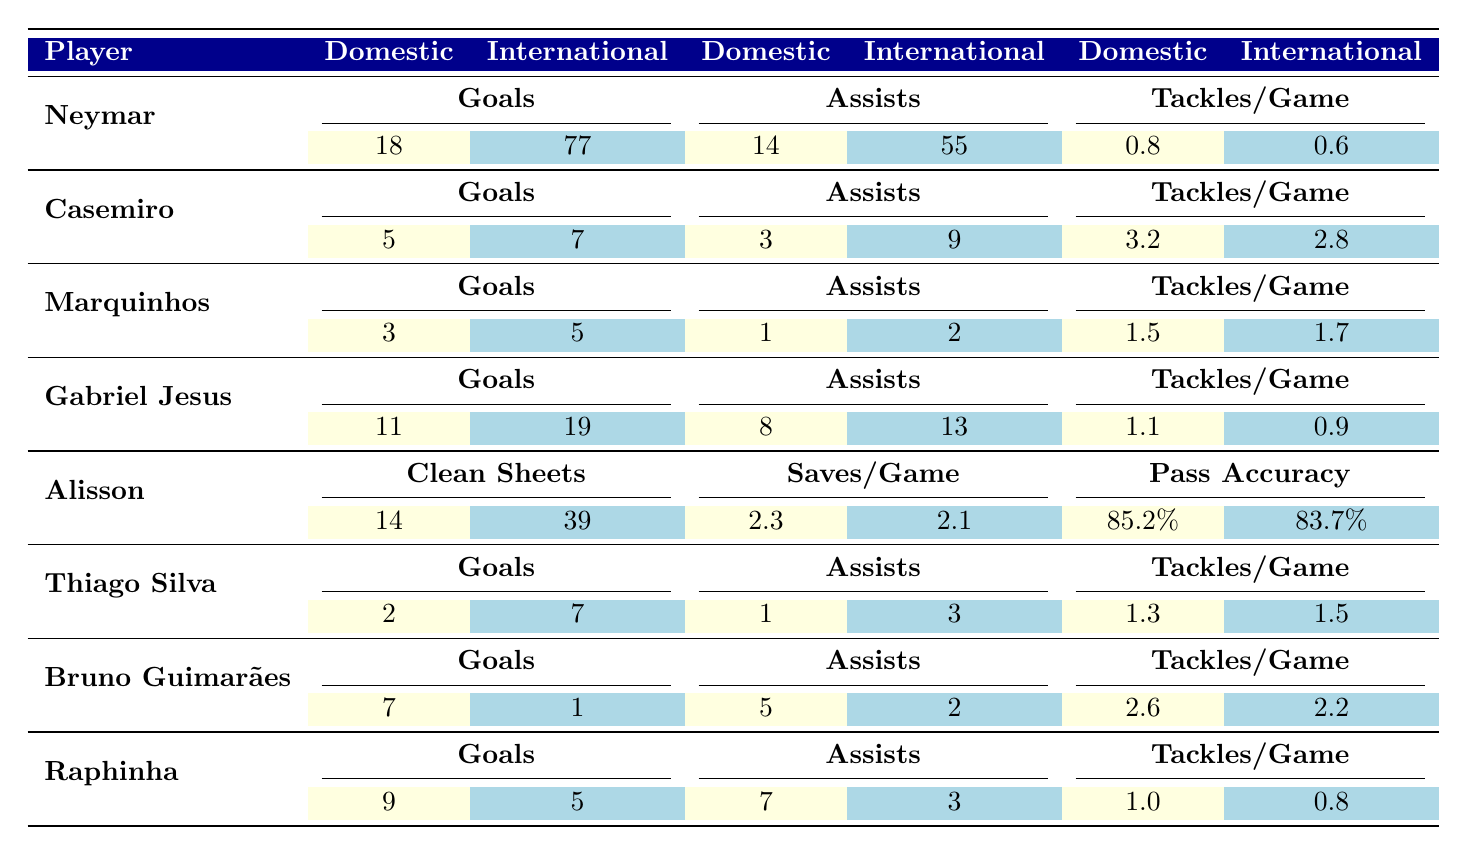What is Neymar's total number of goals scored in both domestic and international matches? Neymar scored 18 goals in domestic matches and 77 in international matches. Adding these together gives 18 + 77 = 95.
Answer: 95 Which player has the highest number of assists in international matches? By comparing the international assist values: Neymar has 55, Casemiro has 9, Gabriel Jesus has 13, Marquinhos has 2, Thiago Silva has 3, Bruno Guimarães has 2, and Raphinha has 3. The highest is Neymar with 55 assists.
Answer: Neymar What is the difference in tackles per game for Casemiro between domestic and international matches? Casemiro has 3.2 tackles per game domestically and 2.8 tackles per game internationally. The difference is 3.2 - 2.8 = 0.4 tackles per game.
Answer: 0.4 Is Gabriel Jesus more effective in terms of assists in domestic matches compared to international matches? Gabriel Jesus has 8 domestic assists and 13 international assists. Since 8 < 13, he is more effective internationally in terms of assists.
Answer: Yes What is the average number of goals scored by Thiago Silva across both match types? Thiago Silva scored 2 goals domestically and 7 internationally, totaling 2 + 7 = 9. Dividing this by the number of match types (2), the average is 9/2 = 4.5.
Answer: 4.5 How many clean sheets did Alisson keep more in international matches than domestic matches? Alisson recorded 39 clean sheets internationally and 14 domestically. The difference is 39 - 14 = 25 more clean sheets internationally.
Answer: 25 Which player has the most overall tackles per game when considering both contexts? The tackles per game for each are: Neymar (0.8, 0.6), Casemiro (3.2, 2.8), Marquinhos (1.5, 1.7), Gabriel Jesus (1.1, 0.9), Thiago Silva (1.3, 1.5), Bruno Guimarães (2.6, 2.2), and Raphinha (1.0, 0.8). Casemiro has the highest average of (3.2 + 2.8) / 2 = 3.0.
Answer: Casemiro What is the combined total of domestic assists from Raphinha and Bruno Guimarães? Raphinha has 7 domestic assists and Bruno Guimarães has 5. Adding these together gives 7 + 5 = 12.
Answer: 12 Did any player keep more clean sheets in domestic matches than in international matches? Looking at the clean sheets, Alisson has 14 domestically and 39 internationally. No player has more clean sheets in domestic matches than in international matches.
Answer: No 